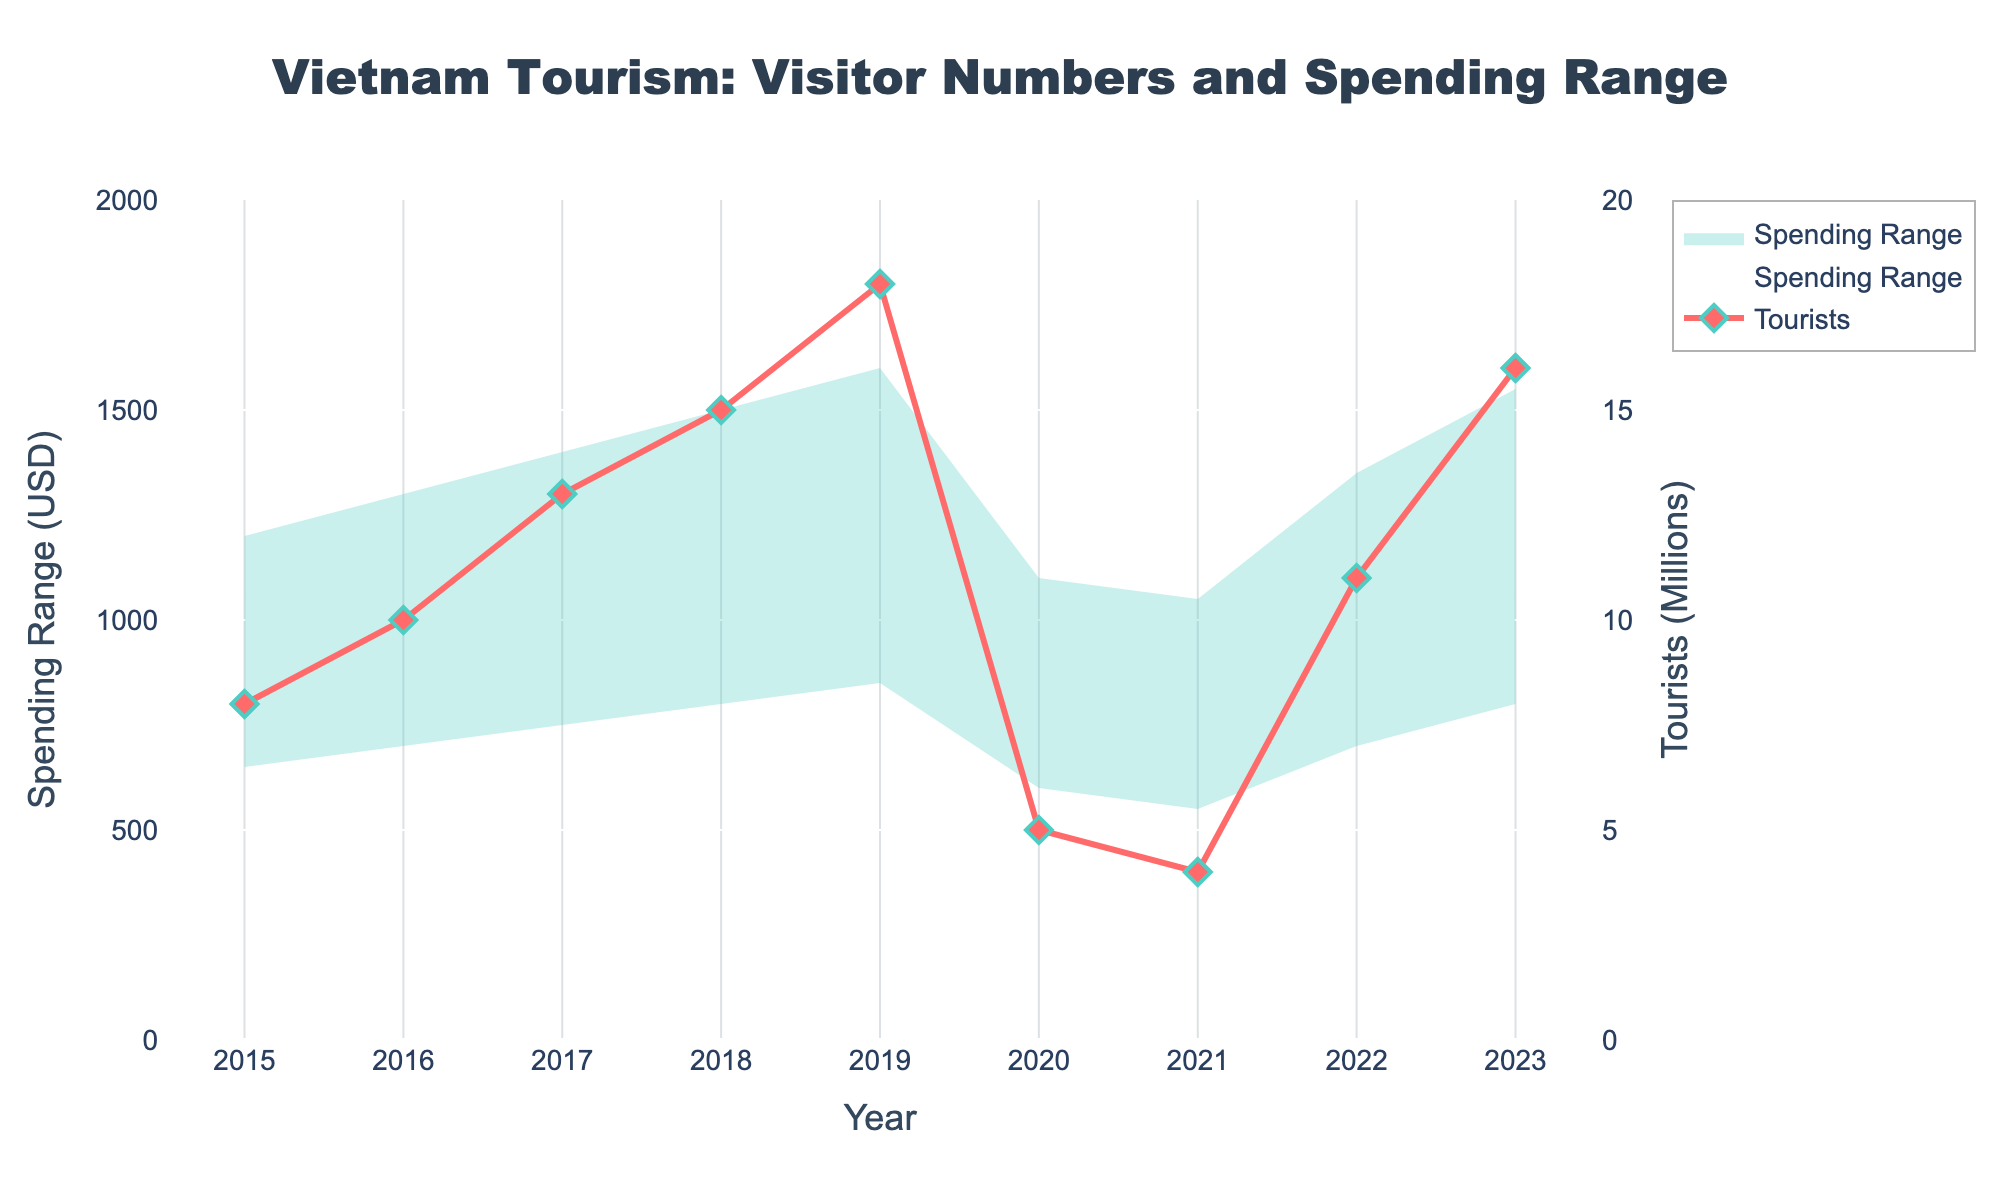What is the title of the chart? The title is usually displayed at the top of the chart and helps in quickly understanding the main theme. Here, it states 'Vietnam Tourism: Visitor Numbers and Spending Range'.
Answer: Vietnam Tourism: Visitor Numbers and Spending Range How many years are covered in this chart? The x-axis of the chart represents the years. By counting the tick marks, we can see that it covers the years from 2015 to 2023.
Answer: 9 What was the maximum number of tourists recorded and in which year? By looking at the peak of the line representing tourists, we can check the y-axis2 on the right which shows the number of tourists in millions. The maximum value reaches 18 million in the year 2019.
Answer: 18 million in 2019 In which year did tourists' average spending range between its lowest bounds? By observing the lower bound of the shaded area representing spending range, the minimum value for spending lies in 2021 at $550.
Answer: 2021 How much did the number of tourists decrease from 2019 to 2020? Checking the value for 2019 and 2020 on the y-axis2 on the right, tourists dropped from 18 million in 2019 to 5 million in 2020. The difference is 18 - 5 = 13 million.
Answer: 13 million How much did the upper bound of average spending per tourist increase between 2015 and 2019? By viewing the upper bound line of the shaded area for 2015 and 2019, it increased from $1200 to $1600. The difference is $1600 - $1200 = $400.
Answer: $400 What was the overall trend in the number of tourists from 2015 to 2023? By tracing the line for tourists from 2015 to 2023, it generally increased from 8 million in 2015 to 16 million in 2023, despite a sharp decline in 2020 and 2021.
Answer: Increasing trend with a dip in 2020 and 2021 Which year experienced the largest drop in the number of tourists compared to the previous year? By observing the steepness of the drop in the line for tourists, the largest drop occurred from 2019 to 2020 where tourists fell from 18 million to 5 million, a 13 million drop.
Answer: 2020 What is the spending range for tourists in the year 2018? By looking at the shaded area for the year 2018, the lower bound is at $800 and the upper bound is at $1500, so the range is $800 to $1500.
Answer: $800 to $1500 Which year had the highest spending lower bound, and what was that value? Observing the shaded area closely, in 2018 the lower bound peaked at $800, making it the highest lower bound for the period.
Answer: 2018 at $800 What is the difference in the upper bound of average tourist spending between 2017 and 2022? The upper bound for 2017 is $1400 and for 2022 is $1350, hence the difference is $1400 - $1350 = $50.
Answer: $50 